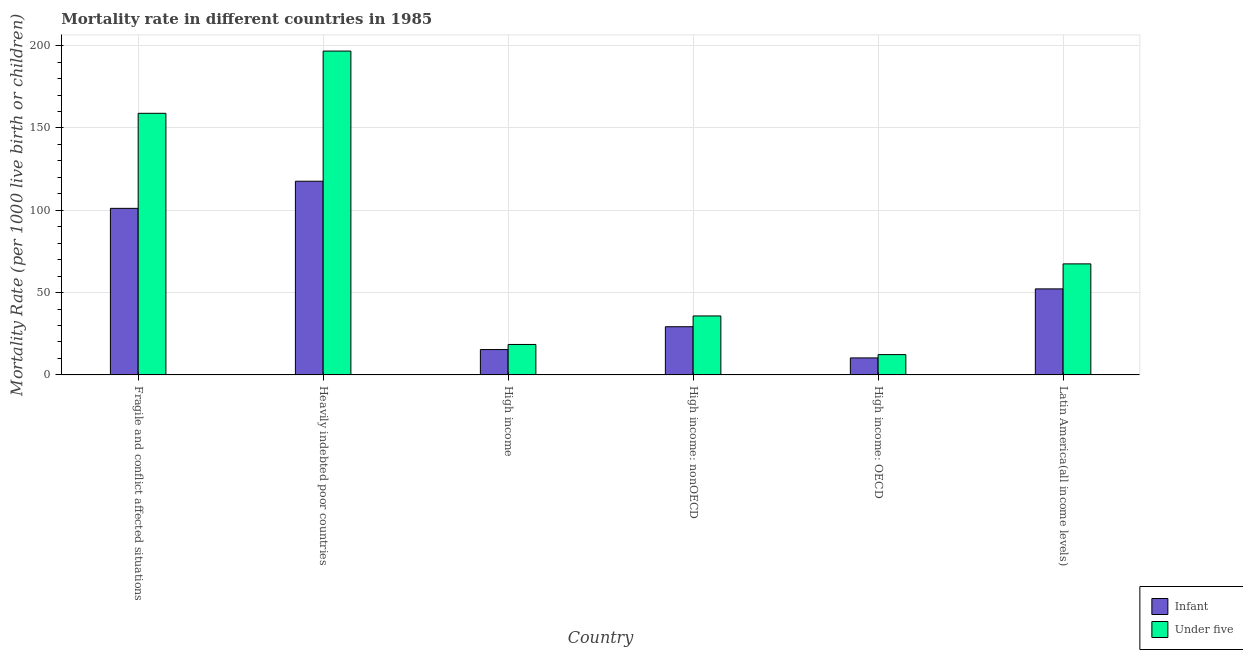How many different coloured bars are there?
Provide a succinct answer. 2. How many bars are there on the 5th tick from the left?
Offer a very short reply. 2. What is the label of the 1st group of bars from the left?
Keep it short and to the point. Fragile and conflict affected situations. In how many cases, is the number of bars for a given country not equal to the number of legend labels?
Provide a short and direct response. 0. What is the under-5 mortality rate in High income?
Offer a very short reply. 18.5. Across all countries, what is the maximum infant mortality rate?
Offer a very short reply. 117.66. Across all countries, what is the minimum under-5 mortality rate?
Give a very brief answer. 12.33. In which country was the under-5 mortality rate maximum?
Provide a short and direct response. Heavily indebted poor countries. In which country was the infant mortality rate minimum?
Keep it short and to the point. High income: OECD. What is the total infant mortality rate in the graph?
Ensure brevity in your answer.  326.1. What is the difference between the infant mortality rate in Fragile and conflict affected situations and that in High income?
Offer a very short reply. 85.78. What is the difference between the infant mortality rate in Latin America(all income levels) and the under-5 mortality rate in Heavily indebted poor countries?
Your response must be concise. -144.47. What is the average infant mortality rate per country?
Keep it short and to the point. 54.35. What is the difference between the infant mortality rate and under-5 mortality rate in High income?
Provide a short and direct response. -3.1. What is the ratio of the infant mortality rate in Fragile and conflict affected situations to that in High income: OECD?
Offer a terse response. 9.8. Is the infant mortality rate in Fragile and conflict affected situations less than that in Heavily indebted poor countries?
Give a very brief answer. Yes. Is the difference between the infant mortality rate in Fragile and conflict affected situations and Latin America(all income levels) greater than the difference between the under-5 mortality rate in Fragile and conflict affected situations and Latin America(all income levels)?
Offer a very short reply. No. What is the difference between the highest and the second highest infant mortality rate?
Your answer should be very brief. 16.48. What is the difference between the highest and the lowest under-5 mortality rate?
Offer a very short reply. 184.4. In how many countries, is the under-5 mortality rate greater than the average under-5 mortality rate taken over all countries?
Give a very brief answer. 2. What does the 2nd bar from the left in High income: nonOECD represents?
Give a very brief answer. Under five. What does the 1st bar from the right in Heavily indebted poor countries represents?
Provide a succinct answer. Under five. Are all the bars in the graph horizontal?
Your answer should be very brief. No. How many countries are there in the graph?
Offer a terse response. 6. Where does the legend appear in the graph?
Your answer should be very brief. Bottom right. What is the title of the graph?
Give a very brief answer. Mortality rate in different countries in 1985. What is the label or title of the Y-axis?
Your answer should be very brief. Mortality Rate (per 1000 live birth or children). What is the Mortality Rate (per 1000 live birth or children) in Infant in Fragile and conflict affected situations?
Your response must be concise. 101.18. What is the Mortality Rate (per 1000 live birth or children) in Under five in Fragile and conflict affected situations?
Your response must be concise. 158.92. What is the Mortality Rate (per 1000 live birth or children) of Infant in Heavily indebted poor countries?
Your response must be concise. 117.66. What is the Mortality Rate (per 1000 live birth or children) of Under five in Heavily indebted poor countries?
Your answer should be compact. 196.73. What is the Mortality Rate (per 1000 live birth or children) in Infant in High income?
Your response must be concise. 15.4. What is the Mortality Rate (per 1000 live birth or children) in Under five in High income?
Give a very brief answer. 18.5. What is the Mortality Rate (per 1000 live birth or children) of Infant in High income: nonOECD?
Keep it short and to the point. 29.27. What is the Mortality Rate (per 1000 live birth or children) of Under five in High income: nonOECD?
Offer a very short reply. 35.83. What is the Mortality Rate (per 1000 live birth or children) of Infant in High income: OECD?
Ensure brevity in your answer.  10.33. What is the Mortality Rate (per 1000 live birth or children) of Under five in High income: OECD?
Offer a very short reply. 12.33. What is the Mortality Rate (per 1000 live birth or children) in Infant in Latin America(all income levels)?
Give a very brief answer. 52.26. What is the Mortality Rate (per 1000 live birth or children) in Under five in Latin America(all income levels)?
Your answer should be compact. 67.45. Across all countries, what is the maximum Mortality Rate (per 1000 live birth or children) of Infant?
Provide a short and direct response. 117.66. Across all countries, what is the maximum Mortality Rate (per 1000 live birth or children) in Under five?
Provide a short and direct response. 196.73. Across all countries, what is the minimum Mortality Rate (per 1000 live birth or children) in Infant?
Make the answer very short. 10.33. Across all countries, what is the minimum Mortality Rate (per 1000 live birth or children) of Under five?
Offer a terse response. 12.33. What is the total Mortality Rate (per 1000 live birth or children) in Infant in the graph?
Make the answer very short. 326.1. What is the total Mortality Rate (per 1000 live birth or children) of Under five in the graph?
Offer a terse response. 489.76. What is the difference between the Mortality Rate (per 1000 live birth or children) of Infant in Fragile and conflict affected situations and that in Heavily indebted poor countries?
Offer a terse response. -16.48. What is the difference between the Mortality Rate (per 1000 live birth or children) in Under five in Fragile and conflict affected situations and that in Heavily indebted poor countries?
Make the answer very short. -37.81. What is the difference between the Mortality Rate (per 1000 live birth or children) of Infant in Fragile and conflict affected situations and that in High income?
Provide a short and direct response. 85.78. What is the difference between the Mortality Rate (per 1000 live birth or children) in Under five in Fragile and conflict affected situations and that in High income?
Provide a short and direct response. 140.42. What is the difference between the Mortality Rate (per 1000 live birth or children) in Infant in Fragile and conflict affected situations and that in High income: nonOECD?
Give a very brief answer. 71.91. What is the difference between the Mortality Rate (per 1000 live birth or children) of Under five in Fragile and conflict affected situations and that in High income: nonOECD?
Your answer should be compact. 123.1. What is the difference between the Mortality Rate (per 1000 live birth or children) in Infant in Fragile and conflict affected situations and that in High income: OECD?
Offer a terse response. 90.85. What is the difference between the Mortality Rate (per 1000 live birth or children) in Under five in Fragile and conflict affected situations and that in High income: OECD?
Give a very brief answer. 146.59. What is the difference between the Mortality Rate (per 1000 live birth or children) of Infant in Fragile and conflict affected situations and that in Latin America(all income levels)?
Provide a short and direct response. 48.92. What is the difference between the Mortality Rate (per 1000 live birth or children) in Under five in Fragile and conflict affected situations and that in Latin America(all income levels)?
Provide a succinct answer. 91.47. What is the difference between the Mortality Rate (per 1000 live birth or children) of Infant in Heavily indebted poor countries and that in High income?
Make the answer very short. 102.26. What is the difference between the Mortality Rate (per 1000 live birth or children) of Under five in Heavily indebted poor countries and that in High income?
Your response must be concise. 178.23. What is the difference between the Mortality Rate (per 1000 live birth or children) of Infant in Heavily indebted poor countries and that in High income: nonOECD?
Make the answer very short. 88.39. What is the difference between the Mortality Rate (per 1000 live birth or children) in Under five in Heavily indebted poor countries and that in High income: nonOECD?
Your answer should be very brief. 160.91. What is the difference between the Mortality Rate (per 1000 live birth or children) of Infant in Heavily indebted poor countries and that in High income: OECD?
Your response must be concise. 107.33. What is the difference between the Mortality Rate (per 1000 live birth or children) in Under five in Heavily indebted poor countries and that in High income: OECD?
Give a very brief answer. 184.4. What is the difference between the Mortality Rate (per 1000 live birth or children) of Infant in Heavily indebted poor countries and that in Latin America(all income levels)?
Offer a terse response. 65.4. What is the difference between the Mortality Rate (per 1000 live birth or children) of Under five in Heavily indebted poor countries and that in Latin America(all income levels)?
Give a very brief answer. 129.28. What is the difference between the Mortality Rate (per 1000 live birth or children) of Infant in High income and that in High income: nonOECD?
Your response must be concise. -13.87. What is the difference between the Mortality Rate (per 1000 live birth or children) of Under five in High income and that in High income: nonOECD?
Provide a short and direct response. -17.33. What is the difference between the Mortality Rate (per 1000 live birth or children) of Infant in High income and that in High income: OECD?
Offer a very short reply. 5.07. What is the difference between the Mortality Rate (per 1000 live birth or children) of Under five in High income and that in High income: OECD?
Your answer should be compact. 6.17. What is the difference between the Mortality Rate (per 1000 live birth or children) in Infant in High income and that in Latin America(all income levels)?
Keep it short and to the point. -36.86. What is the difference between the Mortality Rate (per 1000 live birth or children) of Under five in High income and that in Latin America(all income levels)?
Provide a short and direct response. -48.95. What is the difference between the Mortality Rate (per 1000 live birth or children) in Infant in High income: nonOECD and that in High income: OECD?
Make the answer very short. 18.95. What is the difference between the Mortality Rate (per 1000 live birth or children) in Under five in High income: nonOECD and that in High income: OECD?
Keep it short and to the point. 23.5. What is the difference between the Mortality Rate (per 1000 live birth or children) of Infant in High income: nonOECD and that in Latin America(all income levels)?
Give a very brief answer. -22.99. What is the difference between the Mortality Rate (per 1000 live birth or children) in Under five in High income: nonOECD and that in Latin America(all income levels)?
Offer a terse response. -31.62. What is the difference between the Mortality Rate (per 1000 live birth or children) in Infant in High income: OECD and that in Latin America(all income levels)?
Offer a very short reply. -41.94. What is the difference between the Mortality Rate (per 1000 live birth or children) in Under five in High income: OECD and that in Latin America(all income levels)?
Provide a short and direct response. -55.12. What is the difference between the Mortality Rate (per 1000 live birth or children) in Infant in Fragile and conflict affected situations and the Mortality Rate (per 1000 live birth or children) in Under five in Heavily indebted poor countries?
Keep it short and to the point. -95.55. What is the difference between the Mortality Rate (per 1000 live birth or children) in Infant in Fragile and conflict affected situations and the Mortality Rate (per 1000 live birth or children) in Under five in High income?
Provide a short and direct response. 82.68. What is the difference between the Mortality Rate (per 1000 live birth or children) of Infant in Fragile and conflict affected situations and the Mortality Rate (per 1000 live birth or children) of Under five in High income: nonOECD?
Provide a succinct answer. 65.35. What is the difference between the Mortality Rate (per 1000 live birth or children) in Infant in Fragile and conflict affected situations and the Mortality Rate (per 1000 live birth or children) in Under five in High income: OECD?
Offer a terse response. 88.85. What is the difference between the Mortality Rate (per 1000 live birth or children) in Infant in Fragile and conflict affected situations and the Mortality Rate (per 1000 live birth or children) in Under five in Latin America(all income levels)?
Provide a short and direct response. 33.73. What is the difference between the Mortality Rate (per 1000 live birth or children) in Infant in Heavily indebted poor countries and the Mortality Rate (per 1000 live birth or children) in Under five in High income?
Your answer should be very brief. 99.16. What is the difference between the Mortality Rate (per 1000 live birth or children) in Infant in Heavily indebted poor countries and the Mortality Rate (per 1000 live birth or children) in Under five in High income: nonOECD?
Your answer should be compact. 81.83. What is the difference between the Mortality Rate (per 1000 live birth or children) of Infant in Heavily indebted poor countries and the Mortality Rate (per 1000 live birth or children) of Under five in High income: OECD?
Provide a short and direct response. 105.33. What is the difference between the Mortality Rate (per 1000 live birth or children) in Infant in Heavily indebted poor countries and the Mortality Rate (per 1000 live birth or children) in Under five in Latin America(all income levels)?
Your response must be concise. 50.21. What is the difference between the Mortality Rate (per 1000 live birth or children) of Infant in High income and the Mortality Rate (per 1000 live birth or children) of Under five in High income: nonOECD?
Your answer should be very brief. -20.43. What is the difference between the Mortality Rate (per 1000 live birth or children) of Infant in High income and the Mortality Rate (per 1000 live birth or children) of Under five in High income: OECD?
Your response must be concise. 3.07. What is the difference between the Mortality Rate (per 1000 live birth or children) in Infant in High income and the Mortality Rate (per 1000 live birth or children) in Under five in Latin America(all income levels)?
Your answer should be very brief. -52.05. What is the difference between the Mortality Rate (per 1000 live birth or children) of Infant in High income: nonOECD and the Mortality Rate (per 1000 live birth or children) of Under five in High income: OECD?
Provide a succinct answer. 16.94. What is the difference between the Mortality Rate (per 1000 live birth or children) in Infant in High income: nonOECD and the Mortality Rate (per 1000 live birth or children) in Under five in Latin America(all income levels)?
Offer a terse response. -38.18. What is the difference between the Mortality Rate (per 1000 live birth or children) of Infant in High income: OECD and the Mortality Rate (per 1000 live birth or children) of Under five in Latin America(all income levels)?
Your response must be concise. -57.12. What is the average Mortality Rate (per 1000 live birth or children) in Infant per country?
Keep it short and to the point. 54.35. What is the average Mortality Rate (per 1000 live birth or children) of Under five per country?
Make the answer very short. 81.63. What is the difference between the Mortality Rate (per 1000 live birth or children) in Infant and Mortality Rate (per 1000 live birth or children) in Under five in Fragile and conflict affected situations?
Give a very brief answer. -57.74. What is the difference between the Mortality Rate (per 1000 live birth or children) of Infant and Mortality Rate (per 1000 live birth or children) of Under five in Heavily indebted poor countries?
Give a very brief answer. -79.07. What is the difference between the Mortality Rate (per 1000 live birth or children) in Infant and Mortality Rate (per 1000 live birth or children) in Under five in High income?
Give a very brief answer. -3.1. What is the difference between the Mortality Rate (per 1000 live birth or children) in Infant and Mortality Rate (per 1000 live birth or children) in Under five in High income: nonOECD?
Your response must be concise. -6.56. What is the difference between the Mortality Rate (per 1000 live birth or children) of Infant and Mortality Rate (per 1000 live birth or children) of Under five in High income: OECD?
Give a very brief answer. -2.01. What is the difference between the Mortality Rate (per 1000 live birth or children) in Infant and Mortality Rate (per 1000 live birth or children) in Under five in Latin America(all income levels)?
Your answer should be compact. -15.19. What is the ratio of the Mortality Rate (per 1000 live birth or children) of Infant in Fragile and conflict affected situations to that in Heavily indebted poor countries?
Offer a terse response. 0.86. What is the ratio of the Mortality Rate (per 1000 live birth or children) of Under five in Fragile and conflict affected situations to that in Heavily indebted poor countries?
Offer a terse response. 0.81. What is the ratio of the Mortality Rate (per 1000 live birth or children) in Infant in Fragile and conflict affected situations to that in High income?
Provide a short and direct response. 6.57. What is the ratio of the Mortality Rate (per 1000 live birth or children) of Under five in Fragile and conflict affected situations to that in High income?
Give a very brief answer. 8.59. What is the ratio of the Mortality Rate (per 1000 live birth or children) of Infant in Fragile and conflict affected situations to that in High income: nonOECD?
Offer a terse response. 3.46. What is the ratio of the Mortality Rate (per 1000 live birth or children) in Under five in Fragile and conflict affected situations to that in High income: nonOECD?
Your answer should be very brief. 4.44. What is the ratio of the Mortality Rate (per 1000 live birth or children) of Infant in Fragile and conflict affected situations to that in High income: OECD?
Provide a succinct answer. 9.8. What is the ratio of the Mortality Rate (per 1000 live birth or children) of Under five in Fragile and conflict affected situations to that in High income: OECD?
Offer a terse response. 12.89. What is the ratio of the Mortality Rate (per 1000 live birth or children) in Infant in Fragile and conflict affected situations to that in Latin America(all income levels)?
Your response must be concise. 1.94. What is the ratio of the Mortality Rate (per 1000 live birth or children) in Under five in Fragile and conflict affected situations to that in Latin America(all income levels)?
Give a very brief answer. 2.36. What is the ratio of the Mortality Rate (per 1000 live birth or children) in Infant in Heavily indebted poor countries to that in High income?
Provide a short and direct response. 7.64. What is the ratio of the Mortality Rate (per 1000 live birth or children) of Under five in Heavily indebted poor countries to that in High income?
Keep it short and to the point. 10.63. What is the ratio of the Mortality Rate (per 1000 live birth or children) of Infant in Heavily indebted poor countries to that in High income: nonOECD?
Offer a very short reply. 4.02. What is the ratio of the Mortality Rate (per 1000 live birth or children) in Under five in Heavily indebted poor countries to that in High income: nonOECD?
Keep it short and to the point. 5.49. What is the ratio of the Mortality Rate (per 1000 live birth or children) of Infant in Heavily indebted poor countries to that in High income: OECD?
Offer a terse response. 11.39. What is the ratio of the Mortality Rate (per 1000 live birth or children) in Under five in Heavily indebted poor countries to that in High income: OECD?
Your answer should be very brief. 15.95. What is the ratio of the Mortality Rate (per 1000 live birth or children) of Infant in Heavily indebted poor countries to that in Latin America(all income levels)?
Keep it short and to the point. 2.25. What is the ratio of the Mortality Rate (per 1000 live birth or children) in Under five in Heavily indebted poor countries to that in Latin America(all income levels)?
Provide a short and direct response. 2.92. What is the ratio of the Mortality Rate (per 1000 live birth or children) in Infant in High income to that in High income: nonOECD?
Offer a terse response. 0.53. What is the ratio of the Mortality Rate (per 1000 live birth or children) of Under five in High income to that in High income: nonOECD?
Your answer should be very brief. 0.52. What is the ratio of the Mortality Rate (per 1000 live birth or children) of Infant in High income to that in High income: OECD?
Your answer should be very brief. 1.49. What is the ratio of the Mortality Rate (per 1000 live birth or children) in Under five in High income to that in High income: OECD?
Provide a succinct answer. 1.5. What is the ratio of the Mortality Rate (per 1000 live birth or children) in Infant in High income to that in Latin America(all income levels)?
Offer a terse response. 0.29. What is the ratio of the Mortality Rate (per 1000 live birth or children) in Under five in High income to that in Latin America(all income levels)?
Offer a very short reply. 0.27. What is the ratio of the Mortality Rate (per 1000 live birth or children) in Infant in High income: nonOECD to that in High income: OECD?
Your answer should be very brief. 2.83. What is the ratio of the Mortality Rate (per 1000 live birth or children) in Under five in High income: nonOECD to that in High income: OECD?
Provide a short and direct response. 2.91. What is the ratio of the Mortality Rate (per 1000 live birth or children) in Infant in High income: nonOECD to that in Latin America(all income levels)?
Ensure brevity in your answer.  0.56. What is the ratio of the Mortality Rate (per 1000 live birth or children) in Under five in High income: nonOECD to that in Latin America(all income levels)?
Provide a short and direct response. 0.53. What is the ratio of the Mortality Rate (per 1000 live birth or children) in Infant in High income: OECD to that in Latin America(all income levels)?
Your response must be concise. 0.2. What is the ratio of the Mortality Rate (per 1000 live birth or children) of Under five in High income: OECD to that in Latin America(all income levels)?
Your answer should be very brief. 0.18. What is the difference between the highest and the second highest Mortality Rate (per 1000 live birth or children) in Infant?
Offer a very short reply. 16.48. What is the difference between the highest and the second highest Mortality Rate (per 1000 live birth or children) in Under five?
Provide a succinct answer. 37.81. What is the difference between the highest and the lowest Mortality Rate (per 1000 live birth or children) of Infant?
Offer a very short reply. 107.33. What is the difference between the highest and the lowest Mortality Rate (per 1000 live birth or children) in Under five?
Provide a succinct answer. 184.4. 